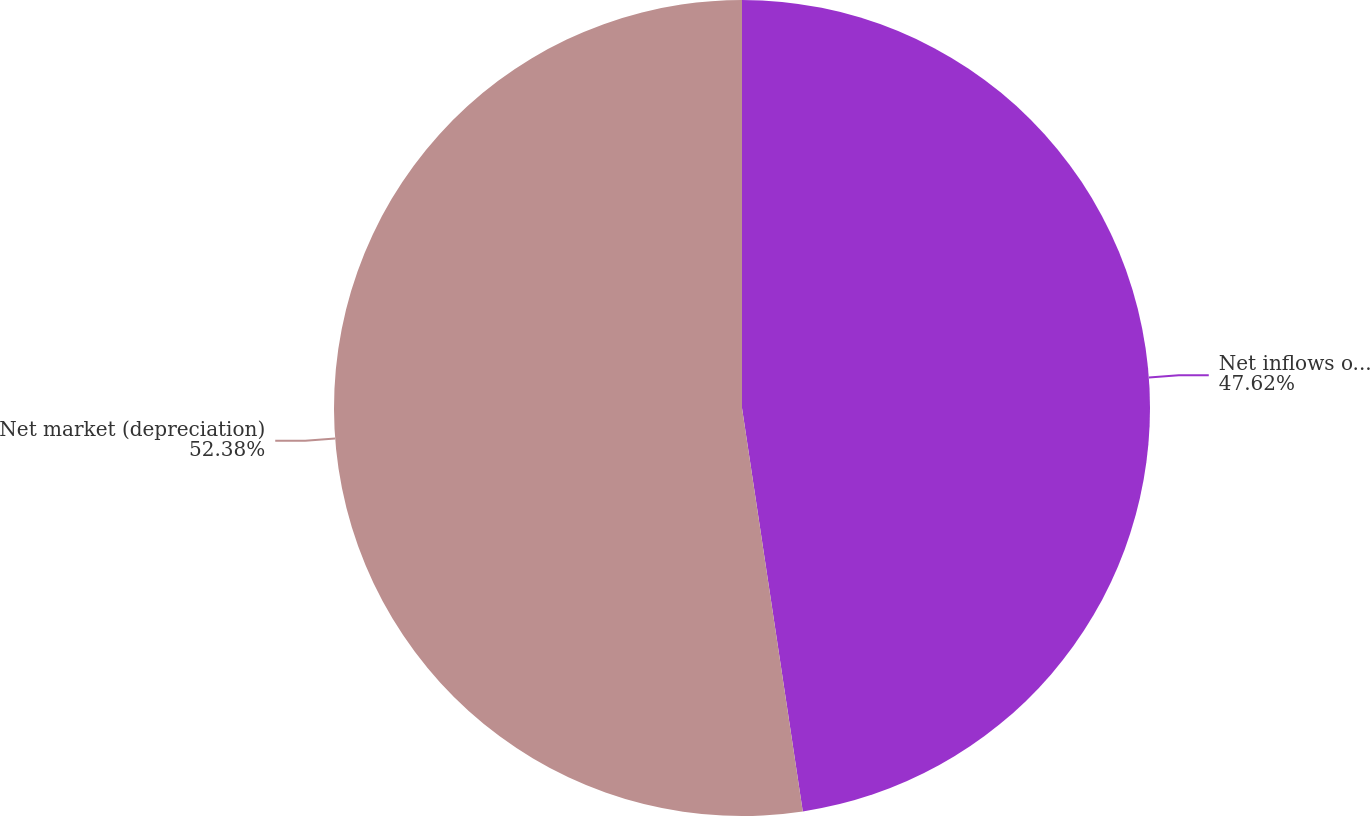<chart> <loc_0><loc_0><loc_500><loc_500><pie_chart><fcel>Net inflows of client assets<fcel>Net market (depreciation)<nl><fcel>47.62%<fcel>52.38%<nl></chart> 